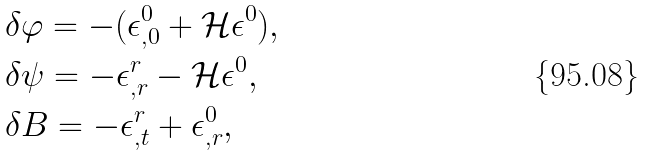<formula> <loc_0><loc_0><loc_500><loc_500>& \delta \varphi = - ( \epsilon ^ { 0 } _ { , 0 } + \mathcal { H } \epsilon ^ { 0 } ) , \\ & \delta \psi = - \epsilon ^ { r } _ { , r } - \mathcal { H } \epsilon ^ { 0 } , \\ & \delta B = - \epsilon ^ { r } _ { , t } + \epsilon ^ { 0 } _ { , r } ,</formula> 